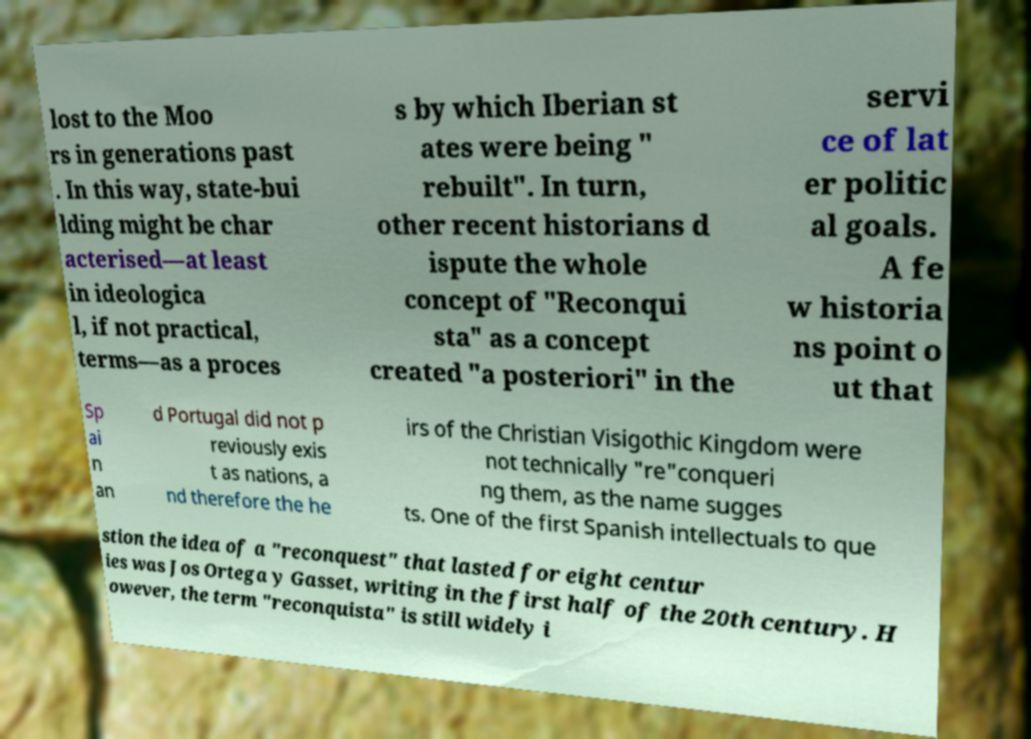For documentation purposes, I need the text within this image transcribed. Could you provide that? lost to the Moo rs in generations past . In this way, state-bui lding might be char acterised—at least in ideologica l, if not practical, terms—as a proces s by which Iberian st ates were being " rebuilt". In turn, other recent historians d ispute the whole concept of "Reconqui sta" as a concept created "a posteriori" in the servi ce of lat er politic al goals. A fe w historia ns point o ut that Sp ai n an d Portugal did not p reviously exis t as nations, a nd therefore the he irs of the Christian Visigothic Kingdom were not technically "re"conqueri ng them, as the name sugges ts. One of the first Spanish intellectuals to que stion the idea of a "reconquest" that lasted for eight centur ies was Jos Ortega y Gasset, writing in the first half of the 20th century. H owever, the term "reconquista" is still widely i 